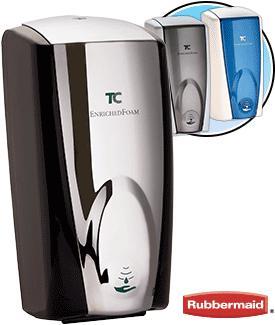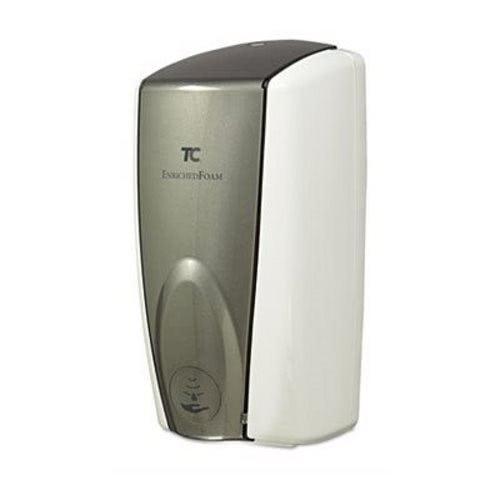The first image is the image on the left, the second image is the image on the right. Assess this claim about the two images: "There are exactly two dispensers.". Correct or not? Answer yes or no. No. The first image is the image on the left, the second image is the image on the right. For the images shown, is this caption "The left and right image contains the same number of wall hanging soap dispensers." true? Answer yes or no. No. 